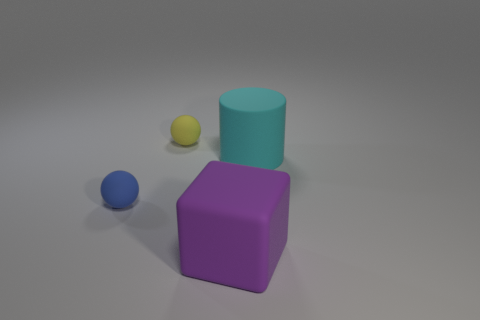Are the small sphere that is behind the blue object and the thing in front of the tiny blue sphere made of the same material?
Make the answer very short. Yes. What number of tiny brown objects are made of the same material as the big cylinder?
Your response must be concise. 0. The rubber cube is what color?
Provide a short and direct response. Purple. There is a tiny object on the left side of the small yellow matte sphere; is it the same shape as the rubber thing that is in front of the blue thing?
Your response must be concise. No. The big rubber object behind the purple block is what color?
Provide a succinct answer. Cyan. Is the number of matte spheres that are left of the yellow rubber object less than the number of cyan rubber things to the right of the cyan cylinder?
Give a very brief answer. No. What number of other objects are the same material as the cube?
Your response must be concise. 3. Is the purple object made of the same material as the blue thing?
Provide a succinct answer. Yes. There is a ball in front of the rubber thing on the right side of the big purple rubber object; what is its size?
Your answer should be very brief. Small. There is a small sphere that is in front of the ball that is behind the big object behind the purple cube; what color is it?
Your answer should be very brief. Blue. 